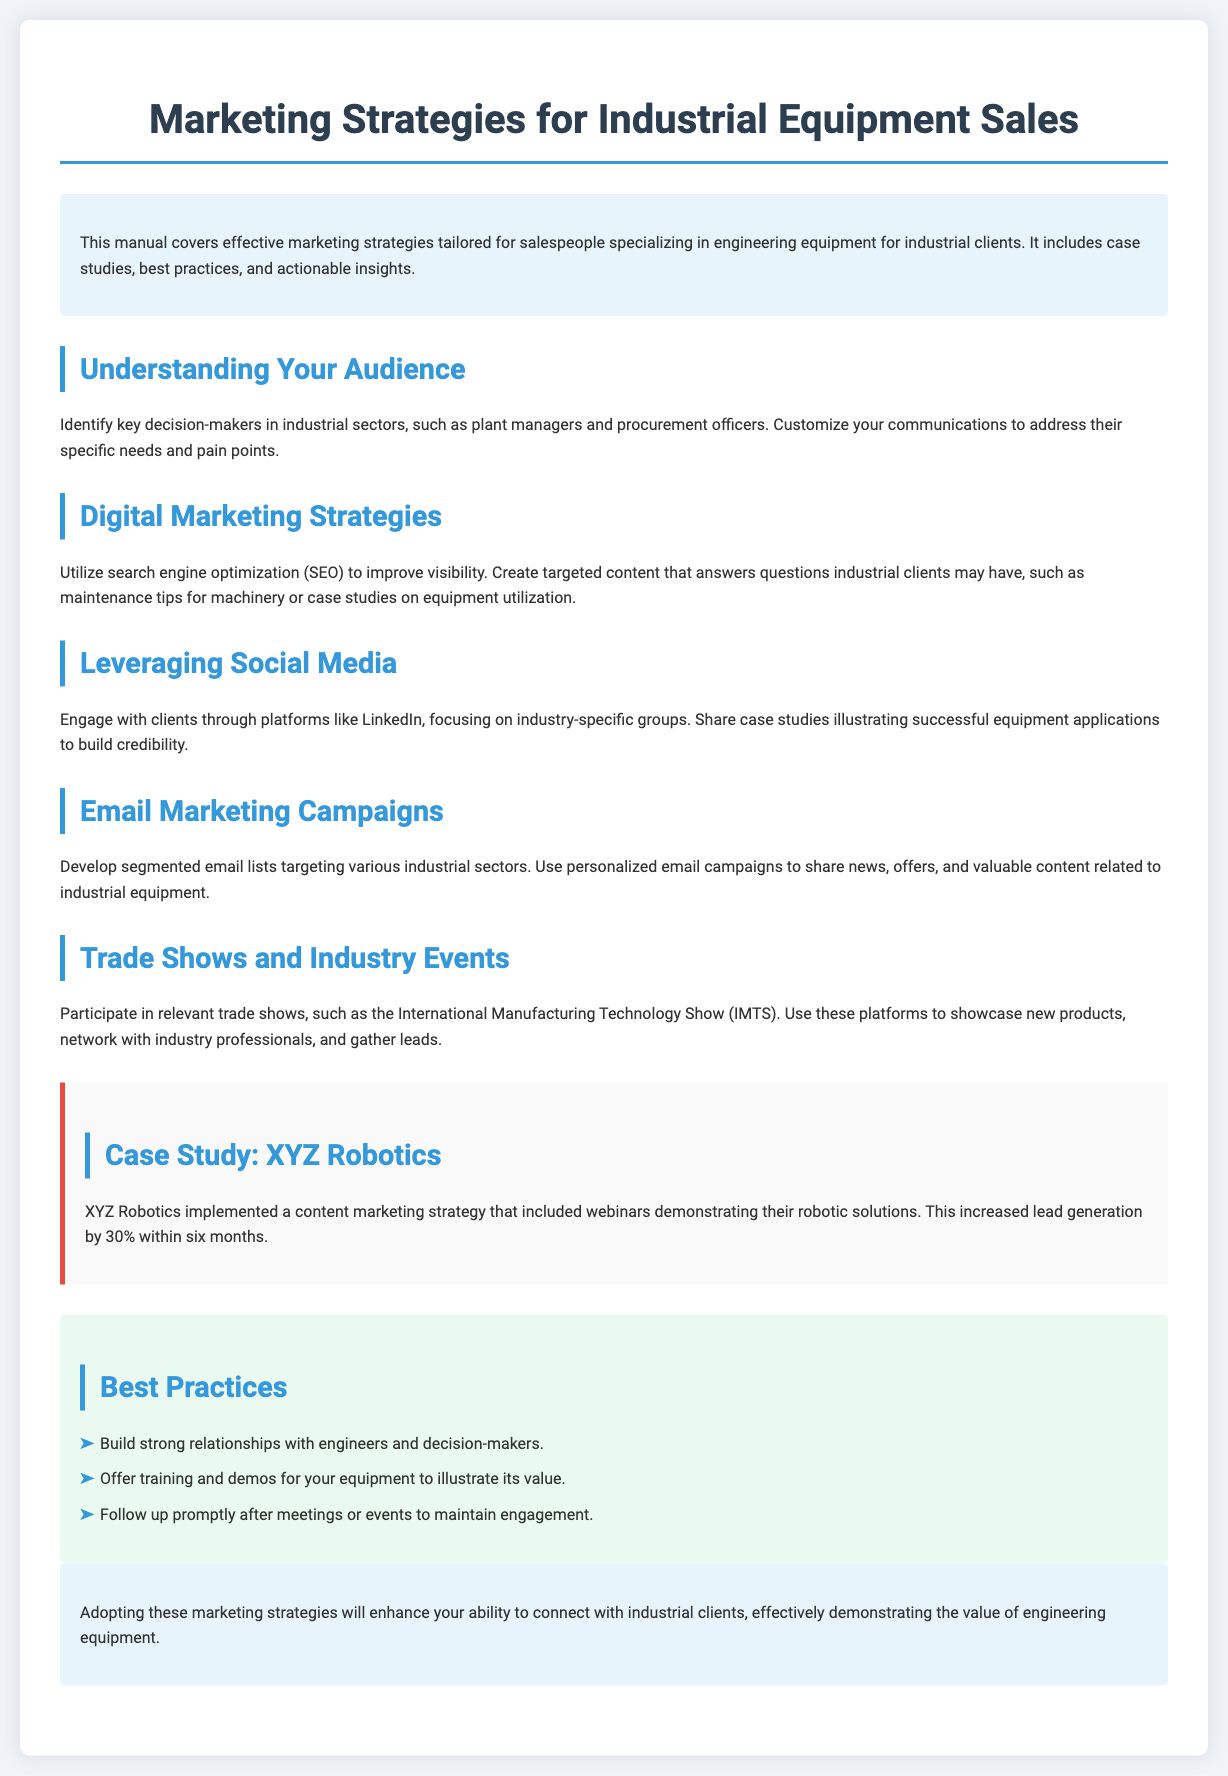What is the title of the manual? The title is provided in the header of the document, which specifies the topic covered.
Answer: Marketing Strategies for Industrial Equipment Sales Who are key decision-makers in industrial sectors? The document identifies specific roles essential for targeting in industrial sales efforts.
Answer: Plant managers and procurement officers What is the percentage increase in lead generation achieved by XYZ Robotics? The case study within the manual states the result of a specific marketing strategy they implemented.
Answer: 30% What event is mentioned for participating in trade shows? A specific trade show name is listed to highlight opportunities for networking and showcasing products.
Answer: International Manufacturing Technology Show (IMTS) Which social media platform is suggested for client engagement? The manual provides a recommendation for a social media platform focusing on industrial connections.
Answer: LinkedIn What type of marketing strategy did XYZ Robotics implement? The case study highlights a particular approach to marketing that was successful for XYZ Robotics.
Answer: Content marketing strategy How many best practices are listed in the document? The number of items in the list indicates the best practices section's depth and recommendations.
Answer: Three What is the main goal of the email marketing campaigns? The document outlines a crucial objective related to targeting specific audiences through personalized communication.
Answer: Share news, offers, and valuable content What color is used for the best practices section background? The design choices of the document include background colors that set sections apart visually.
Answer: Light green 